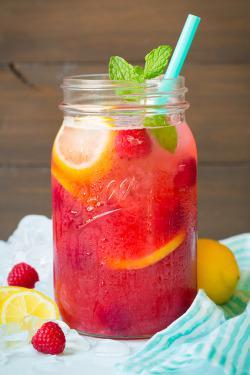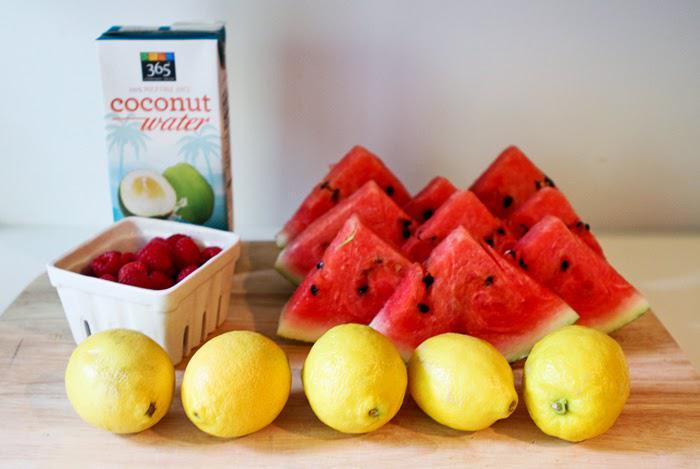The first image is the image on the left, the second image is the image on the right. For the images displayed, is the sentence "There is exactly one straw in a drink." factually correct? Answer yes or no. Yes. 